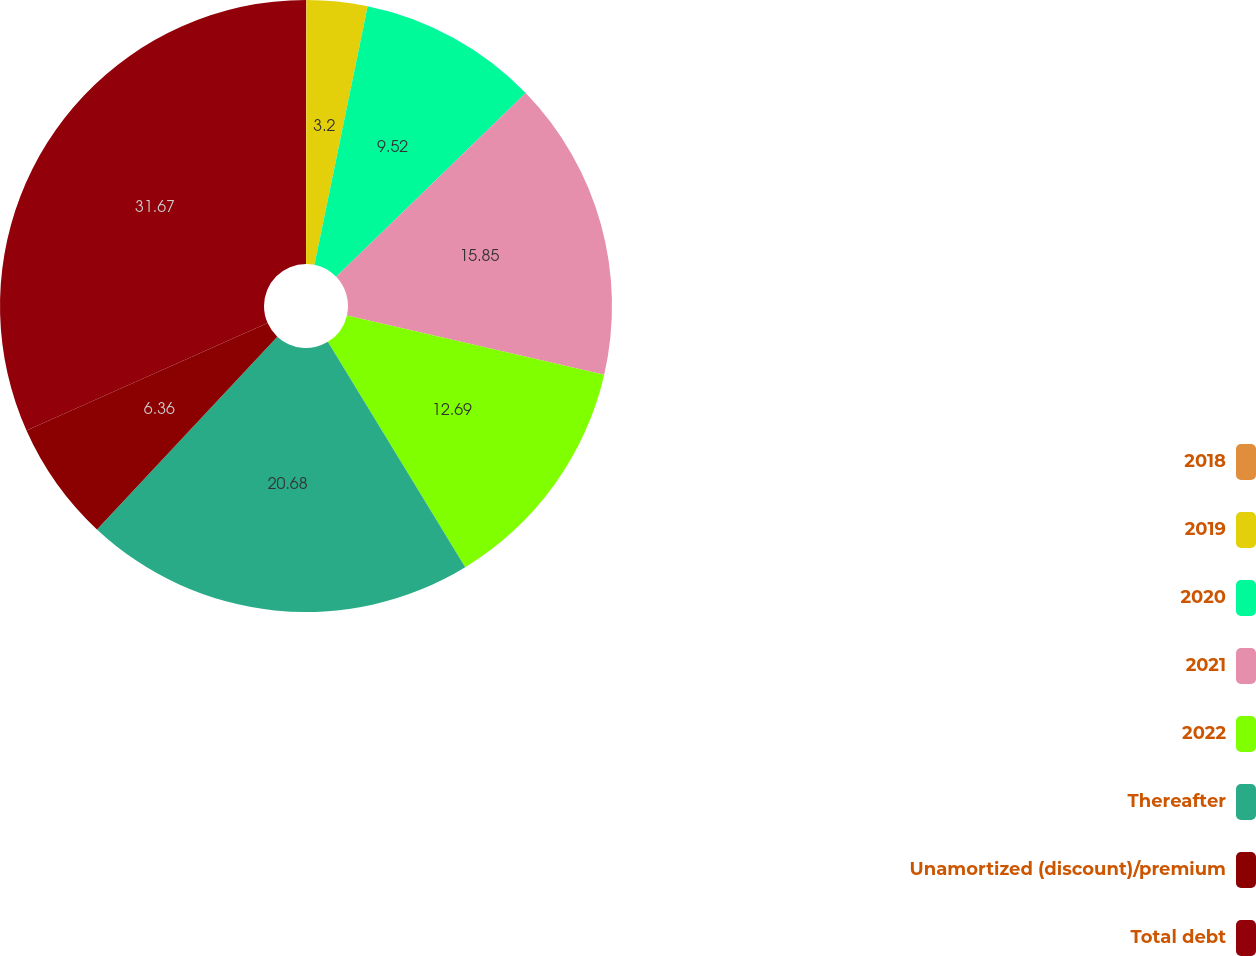<chart> <loc_0><loc_0><loc_500><loc_500><pie_chart><fcel>2018<fcel>2019<fcel>2020<fcel>2021<fcel>2022<fcel>Thereafter<fcel>Unamortized (discount)/premium<fcel>Total debt<nl><fcel>0.03%<fcel>3.2%<fcel>9.52%<fcel>15.85%<fcel>12.69%<fcel>20.68%<fcel>6.36%<fcel>31.67%<nl></chart> 